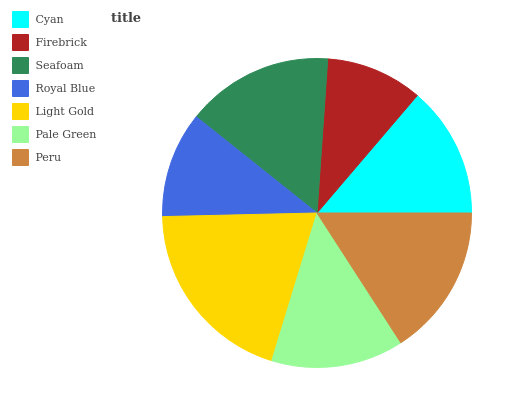Is Firebrick the minimum?
Answer yes or no. Yes. Is Light Gold the maximum?
Answer yes or no. Yes. Is Seafoam the minimum?
Answer yes or no. No. Is Seafoam the maximum?
Answer yes or no. No. Is Seafoam greater than Firebrick?
Answer yes or no. Yes. Is Firebrick less than Seafoam?
Answer yes or no. Yes. Is Firebrick greater than Seafoam?
Answer yes or no. No. Is Seafoam less than Firebrick?
Answer yes or no. No. Is Pale Green the high median?
Answer yes or no. Yes. Is Pale Green the low median?
Answer yes or no. Yes. Is Seafoam the high median?
Answer yes or no. No. Is Seafoam the low median?
Answer yes or no. No. 